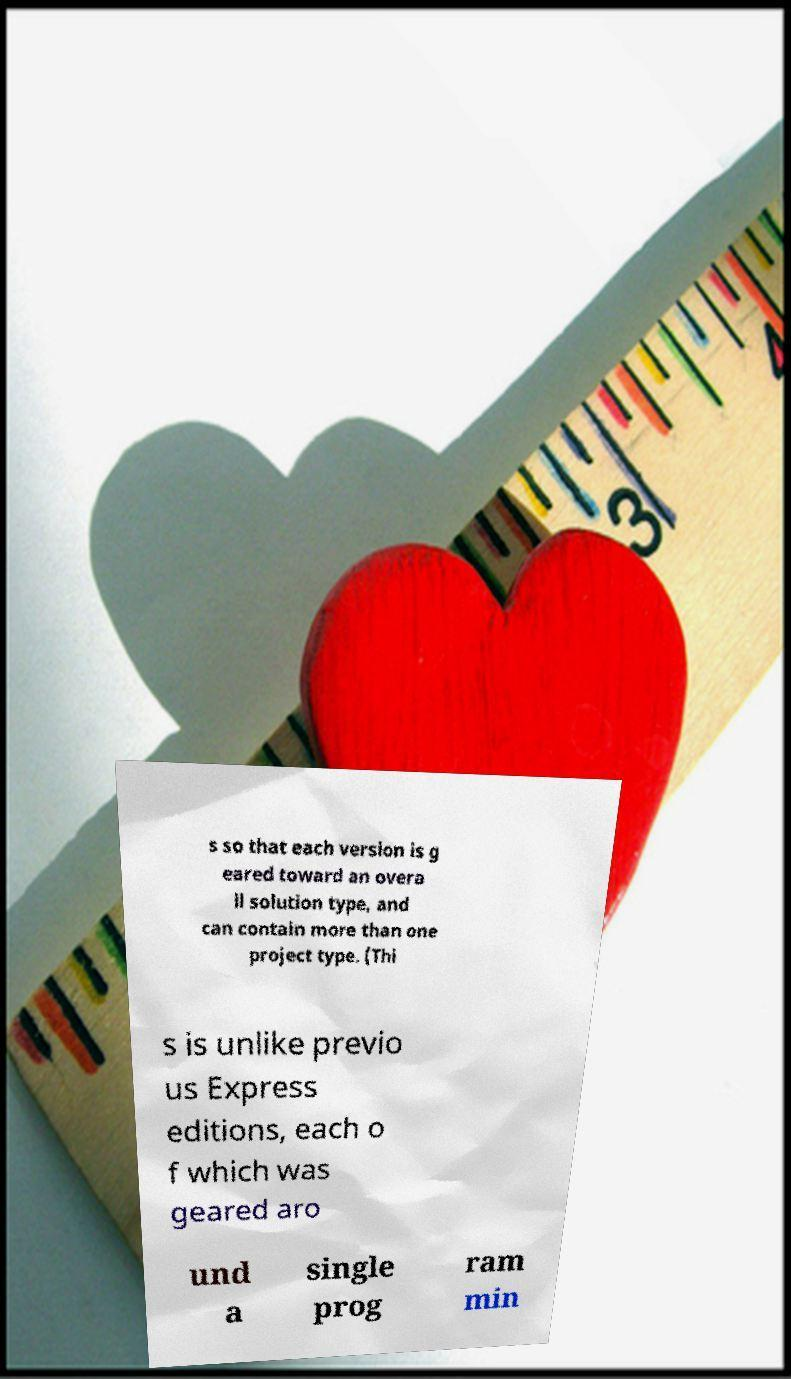Can you accurately transcribe the text from the provided image for me? s so that each version is g eared toward an overa ll solution type, and can contain more than one project type. (Thi s is unlike previo us Express editions, each o f which was geared aro und a single prog ram min 